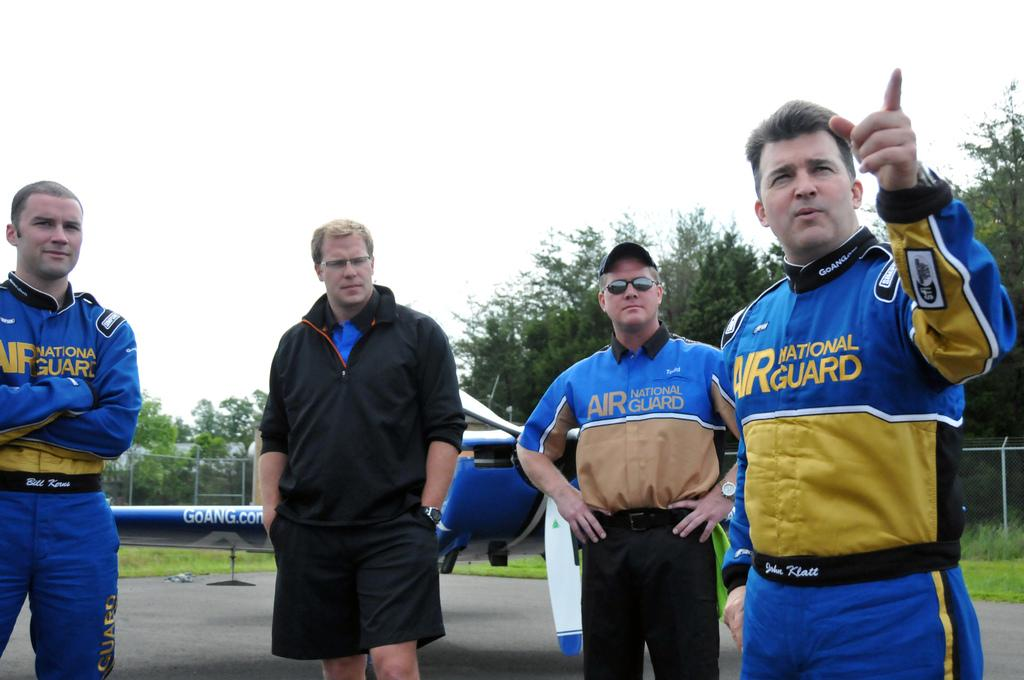<image>
Offer a succinct explanation of the picture presented. The people here are representing the National Guard 